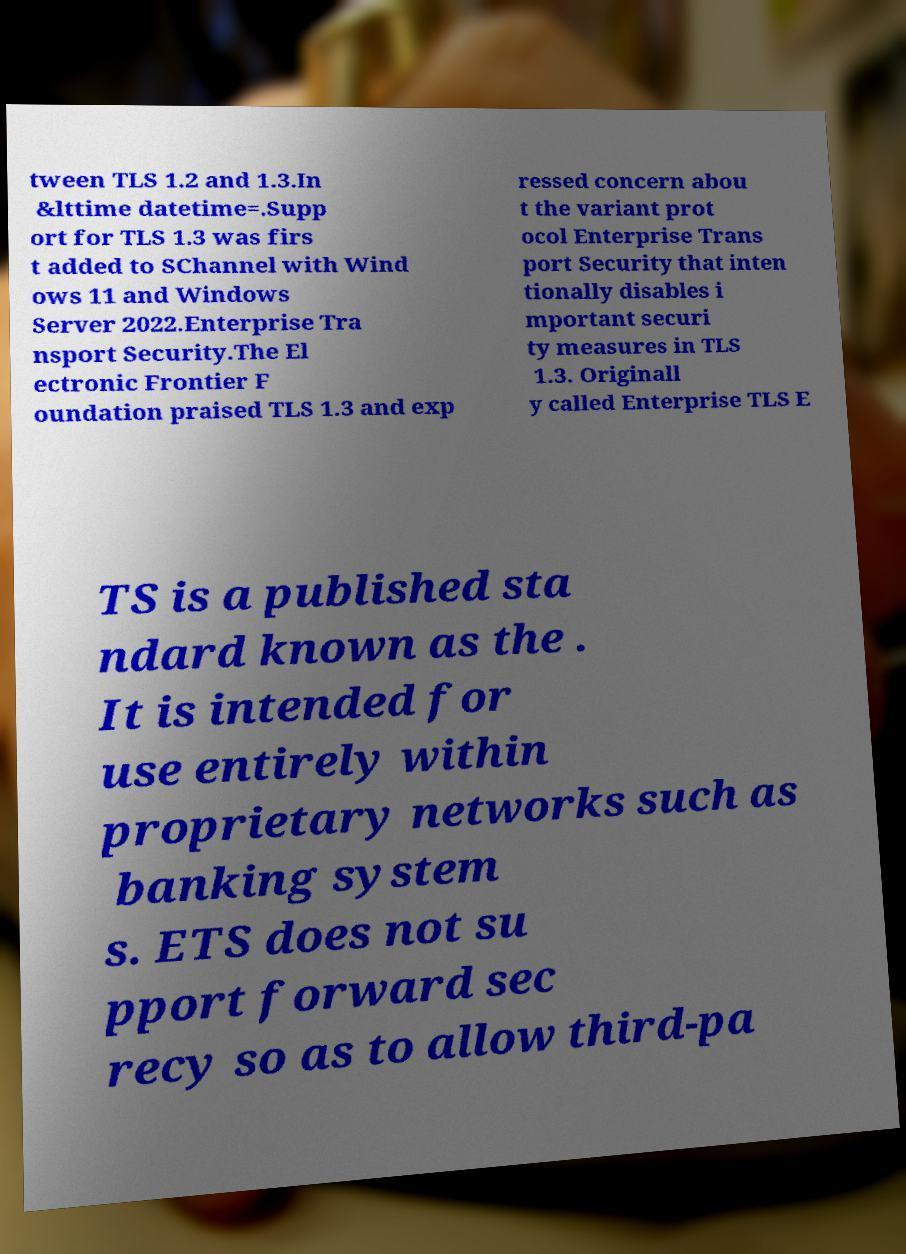Could you extract and type out the text from this image? tween TLS 1.2 and 1.3.In &lttime datetime=.Supp ort for TLS 1.3 was firs t added to SChannel with Wind ows 11 and Windows Server 2022.Enterprise Tra nsport Security.The El ectronic Frontier F oundation praised TLS 1.3 and exp ressed concern abou t the variant prot ocol Enterprise Trans port Security that inten tionally disables i mportant securi ty measures in TLS 1.3. Originall y called Enterprise TLS E TS is a published sta ndard known as the . It is intended for use entirely within proprietary networks such as banking system s. ETS does not su pport forward sec recy so as to allow third-pa 